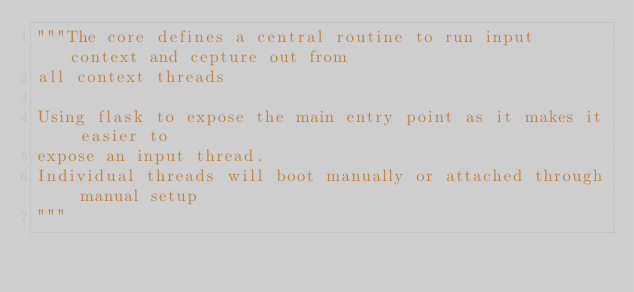Convert code to text. <code><loc_0><loc_0><loc_500><loc_500><_Python_>"""The core defines a central routine to run input context and cepture out from
all context threads

Using flask to expose the main entry point as it makes it easier to
expose an input thread.
Individual threads will boot manually or attached through manual setup
"""
</code> 